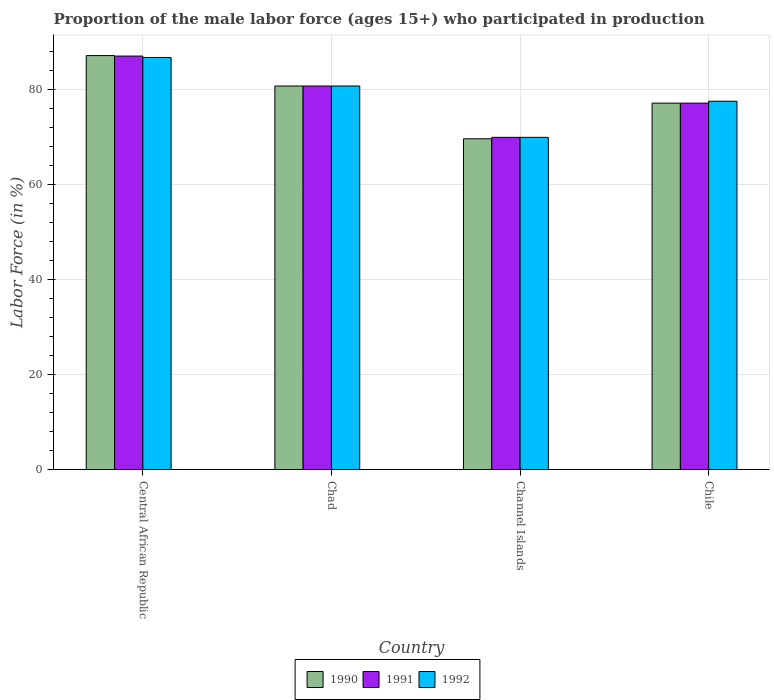How many different coloured bars are there?
Keep it short and to the point. 3. How many bars are there on the 3rd tick from the left?
Your response must be concise. 3. What is the label of the 1st group of bars from the left?
Offer a very short reply. Central African Republic. What is the proportion of the male labor force who participated in production in 1992 in Channel Islands?
Give a very brief answer. 69.9. Across all countries, what is the maximum proportion of the male labor force who participated in production in 1992?
Give a very brief answer. 86.7. Across all countries, what is the minimum proportion of the male labor force who participated in production in 1991?
Give a very brief answer. 69.9. In which country was the proportion of the male labor force who participated in production in 1992 maximum?
Provide a short and direct response. Central African Republic. In which country was the proportion of the male labor force who participated in production in 1990 minimum?
Offer a terse response. Channel Islands. What is the total proportion of the male labor force who participated in production in 1990 in the graph?
Make the answer very short. 314.5. What is the difference between the proportion of the male labor force who participated in production in 1990 in Chile and the proportion of the male labor force who participated in production in 1991 in Chad?
Offer a terse response. -3.6. What is the average proportion of the male labor force who participated in production in 1992 per country?
Provide a succinct answer. 78.7. What is the difference between the proportion of the male labor force who participated in production of/in 1992 and proportion of the male labor force who participated in production of/in 1991 in Chile?
Make the answer very short. 0.4. What is the ratio of the proportion of the male labor force who participated in production in 1990 in Chad to that in Channel Islands?
Your answer should be compact. 1.16. Is the proportion of the male labor force who participated in production in 1991 in Central African Republic less than that in Chile?
Ensure brevity in your answer.  No. What is the difference between the highest and the second highest proportion of the male labor force who participated in production in 1991?
Offer a very short reply. 3.6. What is the difference between the highest and the lowest proportion of the male labor force who participated in production in 1991?
Ensure brevity in your answer.  17.1. What does the 3rd bar from the left in Chad represents?
Provide a short and direct response. 1992. Is it the case that in every country, the sum of the proportion of the male labor force who participated in production in 1990 and proportion of the male labor force who participated in production in 1991 is greater than the proportion of the male labor force who participated in production in 1992?
Provide a succinct answer. Yes. Are all the bars in the graph horizontal?
Give a very brief answer. No. How many countries are there in the graph?
Provide a short and direct response. 4. Does the graph contain grids?
Provide a short and direct response. Yes. Where does the legend appear in the graph?
Offer a terse response. Bottom center. How many legend labels are there?
Provide a succinct answer. 3. How are the legend labels stacked?
Provide a succinct answer. Horizontal. What is the title of the graph?
Provide a short and direct response. Proportion of the male labor force (ages 15+) who participated in production. Does "2010" appear as one of the legend labels in the graph?
Provide a short and direct response. No. What is the label or title of the X-axis?
Ensure brevity in your answer.  Country. What is the Labor Force (in %) in 1990 in Central African Republic?
Provide a short and direct response. 87.1. What is the Labor Force (in %) of 1991 in Central African Republic?
Ensure brevity in your answer.  87. What is the Labor Force (in %) of 1992 in Central African Republic?
Your response must be concise. 86.7. What is the Labor Force (in %) in 1990 in Chad?
Provide a short and direct response. 80.7. What is the Labor Force (in %) in 1991 in Chad?
Your answer should be very brief. 80.7. What is the Labor Force (in %) of 1992 in Chad?
Ensure brevity in your answer.  80.7. What is the Labor Force (in %) in 1990 in Channel Islands?
Your response must be concise. 69.6. What is the Labor Force (in %) of 1991 in Channel Islands?
Offer a very short reply. 69.9. What is the Labor Force (in %) in 1992 in Channel Islands?
Your answer should be very brief. 69.9. What is the Labor Force (in %) in 1990 in Chile?
Your response must be concise. 77.1. What is the Labor Force (in %) of 1991 in Chile?
Offer a terse response. 77.1. What is the Labor Force (in %) of 1992 in Chile?
Provide a short and direct response. 77.5. Across all countries, what is the maximum Labor Force (in %) in 1990?
Keep it short and to the point. 87.1. Across all countries, what is the maximum Labor Force (in %) of 1991?
Make the answer very short. 87. Across all countries, what is the maximum Labor Force (in %) of 1992?
Make the answer very short. 86.7. Across all countries, what is the minimum Labor Force (in %) of 1990?
Give a very brief answer. 69.6. Across all countries, what is the minimum Labor Force (in %) of 1991?
Provide a succinct answer. 69.9. Across all countries, what is the minimum Labor Force (in %) in 1992?
Your answer should be compact. 69.9. What is the total Labor Force (in %) of 1990 in the graph?
Your answer should be very brief. 314.5. What is the total Labor Force (in %) in 1991 in the graph?
Provide a succinct answer. 314.7. What is the total Labor Force (in %) in 1992 in the graph?
Keep it short and to the point. 314.8. What is the difference between the Labor Force (in %) in 1990 in Central African Republic and that in Chad?
Your response must be concise. 6.4. What is the difference between the Labor Force (in %) in 1991 in Central African Republic and that in Chad?
Give a very brief answer. 6.3. What is the difference between the Labor Force (in %) in 1990 in Central African Republic and that in Channel Islands?
Your answer should be very brief. 17.5. What is the difference between the Labor Force (in %) of 1991 in Central African Republic and that in Channel Islands?
Your answer should be compact. 17.1. What is the difference between the Labor Force (in %) of 1990 in Central African Republic and that in Chile?
Your answer should be very brief. 10. What is the difference between the Labor Force (in %) of 1991 in Central African Republic and that in Chile?
Provide a succinct answer. 9.9. What is the difference between the Labor Force (in %) of 1992 in Central African Republic and that in Chile?
Make the answer very short. 9.2. What is the difference between the Labor Force (in %) of 1991 in Chad and that in Channel Islands?
Provide a succinct answer. 10.8. What is the difference between the Labor Force (in %) in 1991 in Channel Islands and that in Chile?
Your answer should be very brief. -7.2. What is the difference between the Labor Force (in %) in 1990 in Central African Republic and the Labor Force (in %) in 1991 in Chad?
Offer a very short reply. 6.4. What is the difference between the Labor Force (in %) in 1990 in Central African Republic and the Labor Force (in %) in 1992 in Chad?
Make the answer very short. 6.4. What is the difference between the Labor Force (in %) of 1991 in Central African Republic and the Labor Force (in %) of 1992 in Chad?
Offer a very short reply. 6.3. What is the difference between the Labor Force (in %) in 1990 in Central African Republic and the Labor Force (in %) in 1991 in Channel Islands?
Offer a very short reply. 17.2. What is the difference between the Labor Force (in %) of 1990 in Central African Republic and the Labor Force (in %) of 1991 in Chile?
Offer a very short reply. 10. What is the difference between the Labor Force (in %) in 1990 in Central African Republic and the Labor Force (in %) in 1992 in Chile?
Your response must be concise. 9.6. What is the difference between the Labor Force (in %) of 1991 in Central African Republic and the Labor Force (in %) of 1992 in Chile?
Ensure brevity in your answer.  9.5. What is the difference between the Labor Force (in %) of 1990 in Chad and the Labor Force (in %) of 1991 in Channel Islands?
Keep it short and to the point. 10.8. What is the difference between the Labor Force (in %) in 1991 in Channel Islands and the Labor Force (in %) in 1992 in Chile?
Make the answer very short. -7.6. What is the average Labor Force (in %) of 1990 per country?
Give a very brief answer. 78.62. What is the average Labor Force (in %) of 1991 per country?
Provide a succinct answer. 78.67. What is the average Labor Force (in %) of 1992 per country?
Offer a terse response. 78.7. What is the difference between the Labor Force (in %) in 1990 and Labor Force (in %) in 1991 in Chad?
Keep it short and to the point. 0. What is the difference between the Labor Force (in %) of 1990 and Labor Force (in %) of 1992 in Chad?
Your response must be concise. 0. What is the difference between the Labor Force (in %) of 1991 and Labor Force (in %) of 1992 in Channel Islands?
Keep it short and to the point. 0. What is the ratio of the Labor Force (in %) of 1990 in Central African Republic to that in Chad?
Make the answer very short. 1.08. What is the ratio of the Labor Force (in %) of 1991 in Central African Republic to that in Chad?
Your answer should be compact. 1.08. What is the ratio of the Labor Force (in %) of 1992 in Central African Republic to that in Chad?
Provide a short and direct response. 1.07. What is the ratio of the Labor Force (in %) in 1990 in Central African Republic to that in Channel Islands?
Keep it short and to the point. 1.25. What is the ratio of the Labor Force (in %) of 1991 in Central African Republic to that in Channel Islands?
Keep it short and to the point. 1.24. What is the ratio of the Labor Force (in %) in 1992 in Central African Republic to that in Channel Islands?
Provide a succinct answer. 1.24. What is the ratio of the Labor Force (in %) of 1990 in Central African Republic to that in Chile?
Offer a terse response. 1.13. What is the ratio of the Labor Force (in %) in 1991 in Central African Republic to that in Chile?
Your answer should be very brief. 1.13. What is the ratio of the Labor Force (in %) of 1992 in Central African Republic to that in Chile?
Give a very brief answer. 1.12. What is the ratio of the Labor Force (in %) of 1990 in Chad to that in Channel Islands?
Your response must be concise. 1.16. What is the ratio of the Labor Force (in %) in 1991 in Chad to that in Channel Islands?
Offer a very short reply. 1.15. What is the ratio of the Labor Force (in %) of 1992 in Chad to that in Channel Islands?
Keep it short and to the point. 1.15. What is the ratio of the Labor Force (in %) of 1990 in Chad to that in Chile?
Offer a terse response. 1.05. What is the ratio of the Labor Force (in %) of 1991 in Chad to that in Chile?
Your answer should be compact. 1.05. What is the ratio of the Labor Force (in %) in 1992 in Chad to that in Chile?
Provide a succinct answer. 1.04. What is the ratio of the Labor Force (in %) of 1990 in Channel Islands to that in Chile?
Your answer should be very brief. 0.9. What is the ratio of the Labor Force (in %) in 1991 in Channel Islands to that in Chile?
Offer a very short reply. 0.91. What is the ratio of the Labor Force (in %) of 1992 in Channel Islands to that in Chile?
Your response must be concise. 0.9. What is the difference between the highest and the second highest Labor Force (in %) in 1990?
Make the answer very short. 6.4. What is the difference between the highest and the lowest Labor Force (in %) of 1992?
Provide a short and direct response. 16.8. 